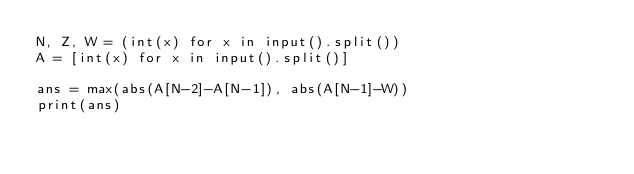Convert code to text. <code><loc_0><loc_0><loc_500><loc_500><_Python_>N, Z, W = (int(x) for x in input().split())
A = [int(x) for x in input().split()]

ans = max(abs(A[N-2]-A[N-1]), abs(A[N-1]-W))
print(ans)</code> 